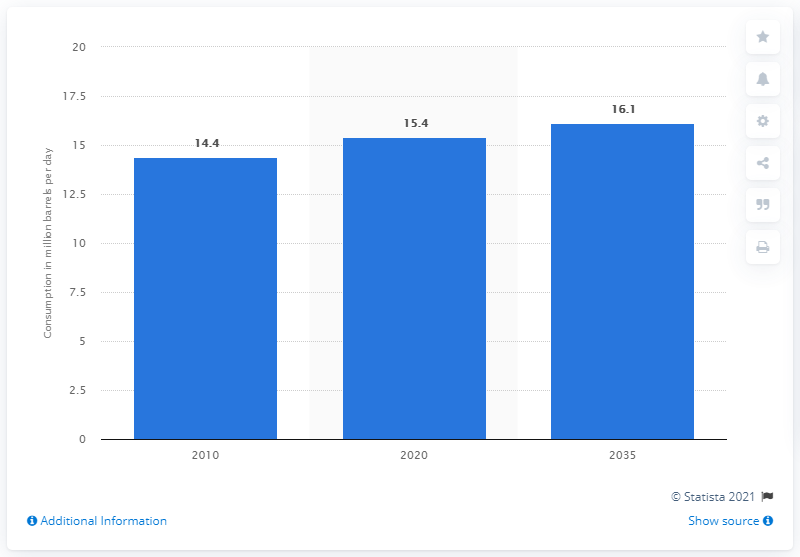Draw attention to some important aspects in this diagram. By 2020, it is expected that the industry sector will consume approximately 15.4 barrels of oil. 